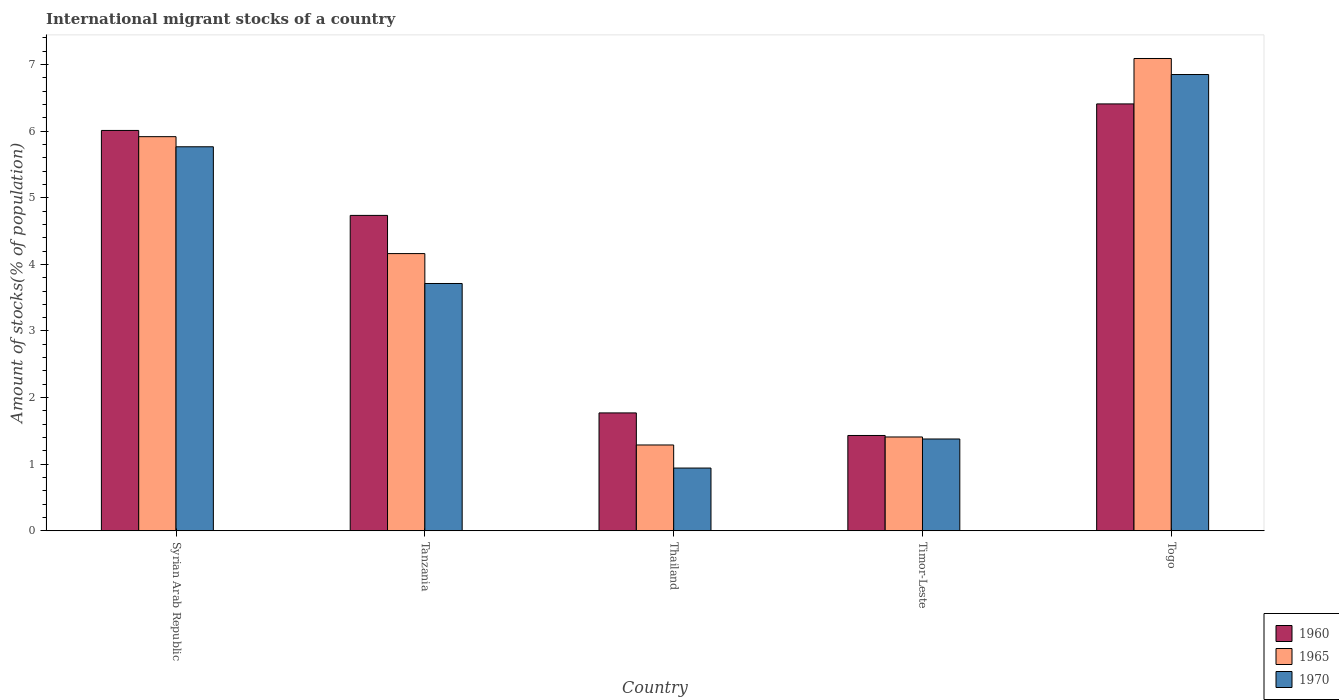How many different coloured bars are there?
Give a very brief answer. 3. How many bars are there on the 1st tick from the left?
Make the answer very short. 3. What is the label of the 5th group of bars from the left?
Keep it short and to the point. Togo. In how many cases, is the number of bars for a given country not equal to the number of legend labels?
Keep it short and to the point. 0. What is the amount of stocks in in 1970 in Syrian Arab Republic?
Your response must be concise. 5.77. Across all countries, what is the maximum amount of stocks in in 1970?
Make the answer very short. 6.85. Across all countries, what is the minimum amount of stocks in in 1970?
Your response must be concise. 0.94. In which country was the amount of stocks in in 1965 maximum?
Your response must be concise. Togo. In which country was the amount of stocks in in 1960 minimum?
Provide a short and direct response. Timor-Leste. What is the total amount of stocks in in 1970 in the graph?
Provide a short and direct response. 18.65. What is the difference between the amount of stocks in in 1970 in Syrian Arab Republic and that in Tanzania?
Provide a short and direct response. 2.05. What is the difference between the amount of stocks in in 1965 in Timor-Leste and the amount of stocks in in 1960 in Thailand?
Your answer should be compact. -0.36. What is the average amount of stocks in in 1965 per country?
Offer a terse response. 3.97. What is the difference between the amount of stocks in of/in 1970 and amount of stocks in of/in 1965 in Thailand?
Provide a short and direct response. -0.35. What is the ratio of the amount of stocks in in 1965 in Syrian Arab Republic to that in Thailand?
Keep it short and to the point. 4.59. Is the amount of stocks in in 1960 in Timor-Leste less than that in Togo?
Make the answer very short. Yes. What is the difference between the highest and the second highest amount of stocks in in 1960?
Your answer should be very brief. -1.67. What is the difference between the highest and the lowest amount of stocks in in 1970?
Offer a very short reply. 5.91. In how many countries, is the amount of stocks in in 1960 greater than the average amount of stocks in in 1960 taken over all countries?
Your answer should be compact. 3. What does the 2nd bar from the left in Timor-Leste represents?
Provide a succinct answer. 1965. What is the difference between two consecutive major ticks on the Y-axis?
Your response must be concise. 1. Are the values on the major ticks of Y-axis written in scientific E-notation?
Provide a short and direct response. No. Does the graph contain grids?
Make the answer very short. No. How many legend labels are there?
Your answer should be very brief. 3. How are the legend labels stacked?
Keep it short and to the point. Vertical. What is the title of the graph?
Your response must be concise. International migrant stocks of a country. Does "2015" appear as one of the legend labels in the graph?
Your answer should be very brief. No. What is the label or title of the Y-axis?
Offer a terse response. Amount of stocks(% of population). What is the Amount of stocks(% of population) in 1960 in Syrian Arab Republic?
Keep it short and to the point. 6.01. What is the Amount of stocks(% of population) in 1965 in Syrian Arab Republic?
Offer a very short reply. 5.92. What is the Amount of stocks(% of population) in 1970 in Syrian Arab Republic?
Ensure brevity in your answer.  5.77. What is the Amount of stocks(% of population) in 1960 in Tanzania?
Ensure brevity in your answer.  4.73. What is the Amount of stocks(% of population) in 1965 in Tanzania?
Offer a very short reply. 4.16. What is the Amount of stocks(% of population) of 1970 in Tanzania?
Make the answer very short. 3.71. What is the Amount of stocks(% of population) of 1960 in Thailand?
Make the answer very short. 1.77. What is the Amount of stocks(% of population) of 1965 in Thailand?
Keep it short and to the point. 1.29. What is the Amount of stocks(% of population) in 1970 in Thailand?
Your response must be concise. 0.94. What is the Amount of stocks(% of population) in 1960 in Timor-Leste?
Offer a very short reply. 1.43. What is the Amount of stocks(% of population) of 1965 in Timor-Leste?
Offer a terse response. 1.41. What is the Amount of stocks(% of population) in 1970 in Timor-Leste?
Make the answer very short. 1.38. What is the Amount of stocks(% of population) in 1960 in Togo?
Make the answer very short. 6.41. What is the Amount of stocks(% of population) in 1965 in Togo?
Give a very brief answer. 7.09. What is the Amount of stocks(% of population) of 1970 in Togo?
Your answer should be compact. 6.85. Across all countries, what is the maximum Amount of stocks(% of population) in 1960?
Keep it short and to the point. 6.41. Across all countries, what is the maximum Amount of stocks(% of population) of 1965?
Give a very brief answer. 7.09. Across all countries, what is the maximum Amount of stocks(% of population) in 1970?
Give a very brief answer. 6.85. Across all countries, what is the minimum Amount of stocks(% of population) in 1960?
Make the answer very short. 1.43. Across all countries, what is the minimum Amount of stocks(% of population) in 1965?
Your answer should be compact. 1.29. Across all countries, what is the minimum Amount of stocks(% of population) in 1970?
Your answer should be compact. 0.94. What is the total Amount of stocks(% of population) in 1960 in the graph?
Your response must be concise. 20.35. What is the total Amount of stocks(% of population) of 1965 in the graph?
Your response must be concise. 19.87. What is the total Amount of stocks(% of population) of 1970 in the graph?
Offer a terse response. 18.65. What is the difference between the Amount of stocks(% of population) in 1960 in Syrian Arab Republic and that in Tanzania?
Ensure brevity in your answer.  1.28. What is the difference between the Amount of stocks(% of population) of 1965 in Syrian Arab Republic and that in Tanzania?
Offer a very short reply. 1.76. What is the difference between the Amount of stocks(% of population) in 1970 in Syrian Arab Republic and that in Tanzania?
Make the answer very short. 2.05. What is the difference between the Amount of stocks(% of population) of 1960 in Syrian Arab Republic and that in Thailand?
Ensure brevity in your answer.  4.24. What is the difference between the Amount of stocks(% of population) of 1965 in Syrian Arab Republic and that in Thailand?
Give a very brief answer. 4.63. What is the difference between the Amount of stocks(% of population) of 1970 in Syrian Arab Republic and that in Thailand?
Offer a very short reply. 4.82. What is the difference between the Amount of stocks(% of population) of 1960 in Syrian Arab Republic and that in Timor-Leste?
Your answer should be very brief. 4.58. What is the difference between the Amount of stocks(% of population) of 1965 in Syrian Arab Republic and that in Timor-Leste?
Offer a very short reply. 4.51. What is the difference between the Amount of stocks(% of population) of 1970 in Syrian Arab Republic and that in Timor-Leste?
Provide a short and direct response. 4.39. What is the difference between the Amount of stocks(% of population) of 1960 in Syrian Arab Republic and that in Togo?
Offer a terse response. -0.4. What is the difference between the Amount of stocks(% of population) of 1965 in Syrian Arab Republic and that in Togo?
Offer a very short reply. -1.17. What is the difference between the Amount of stocks(% of population) of 1970 in Syrian Arab Republic and that in Togo?
Your answer should be very brief. -1.08. What is the difference between the Amount of stocks(% of population) in 1960 in Tanzania and that in Thailand?
Offer a terse response. 2.97. What is the difference between the Amount of stocks(% of population) in 1965 in Tanzania and that in Thailand?
Your answer should be very brief. 2.87. What is the difference between the Amount of stocks(% of population) of 1970 in Tanzania and that in Thailand?
Your answer should be compact. 2.77. What is the difference between the Amount of stocks(% of population) of 1960 in Tanzania and that in Timor-Leste?
Make the answer very short. 3.3. What is the difference between the Amount of stocks(% of population) of 1965 in Tanzania and that in Timor-Leste?
Ensure brevity in your answer.  2.75. What is the difference between the Amount of stocks(% of population) in 1970 in Tanzania and that in Timor-Leste?
Make the answer very short. 2.33. What is the difference between the Amount of stocks(% of population) of 1960 in Tanzania and that in Togo?
Give a very brief answer. -1.67. What is the difference between the Amount of stocks(% of population) in 1965 in Tanzania and that in Togo?
Offer a terse response. -2.93. What is the difference between the Amount of stocks(% of population) of 1970 in Tanzania and that in Togo?
Offer a terse response. -3.14. What is the difference between the Amount of stocks(% of population) in 1960 in Thailand and that in Timor-Leste?
Make the answer very short. 0.34. What is the difference between the Amount of stocks(% of population) in 1965 in Thailand and that in Timor-Leste?
Give a very brief answer. -0.12. What is the difference between the Amount of stocks(% of population) in 1970 in Thailand and that in Timor-Leste?
Offer a terse response. -0.44. What is the difference between the Amount of stocks(% of population) in 1960 in Thailand and that in Togo?
Ensure brevity in your answer.  -4.64. What is the difference between the Amount of stocks(% of population) of 1965 in Thailand and that in Togo?
Offer a terse response. -5.8. What is the difference between the Amount of stocks(% of population) of 1970 in Thailand and that in Togo?
Provide a succinct answer. -5.91. What is the difference between the Amount of stocks(% of population) in 1960 in Timor-Leste and that in Togo?
Make the answer very short. -4.98. What is the difference between the Amount of stocks(% of population) of 1965 in Timor-Leste and that in Togo?
Keep it short and to the point. -5.68. What is the difference between the Amount of stocks(% of population) in 1970 in Timor-Leste and that in Togo?
Provide a succinct answer. -5.47. What is the difference between the Amount of stocks(% of population) of 1960 in Syrian Arab Republic and the Amount of stocks(% of population) of 1965 in Tanzania?
Offer a terse response. 1.85. What is the difference between the Amount of stocks(% of population) in 1960 in Syrian Arab Republic and the Amount of stocks(% of population) in 1970 in Tanzania?
Give a very brief answer. 2.3. What is the difference between the Amount of stocks(% of population) of 1965 in Syrian Arab Republic and the Amount of stocks(% of population) of 1970 in Tanzania?
Give a very brief answer. 2.2. What is the difference between the Amount of stocks(% of population) of 1960 in Syrian Arab Republic and the Amount of stocks(% of population) of 1965 in Thailand?
Your answer should be compact. 4.72. What is the difference between the Amount of stocks(% of population) of 1960 in Syrian Arab Republic and the Amount of stocks(% of population) of 1970 in Thailand?
Provide a short and direct response. 5.07. What is the difference between the Amount of stocks(% of population) in 1965 in Syrian Arab Republic and the Amount of stocks(% of population) in 1970 in Thailand?
Your response must be concise. 4.98. What is the difference between the Amount of stocks(% of population) of 1960 in Syrian Arab Republic and the Amount of stocks(% of population) of 1965 in Timor-Leste?
Give a very brief answer. 4.6. What is the difference between the Amount of stocks(% of population) in 1960 in Syrian Arab Republic and the Amount of stocks(% of population) in 1970 in Timor-Leste?
Offer a terse response. 4.63. What is the difference between the Amount of stocks(% of population) in 1965 in Syrian Arab Republic and the Amount of stocks(% of population) in 1970 in Timor-Leste?
Your response must be concise. 4.54. What is the difference between the Amount of stocks(% of population) of 1960 in Syrian Arab Republic and the Amount of stocks(% of population) of 1965 in Togo?
Your response must be concise. -1.08. What is the difference between the Amount of stocks(% of population) of 1960 in Syrian Arab Republic and the Amount of stocks(% of population) of 1970 in Togo?
Provide a short and direct response. -0.84. What is the difference between the Amount of stocks(% of population) of 1965 in Syrian Arab Republic and the Amount of stocks(% of population) of 1970 in Togo?
Offer a very short reply. -0.93. What is the difference between the Amount of stocks(% of population) in 1960 in Tanzania and the Amount of stocks(% of population) in 1965 in Thailand?
Ensure brevity in your answer.  3.45. What is the difference between the Amount of stocks(% of population) of 1960 in Tanzania and the Amount of stocks(% of population) of 1970 in Thailand?
Your answer should be compact. 3.79. What is the difference between the Amount of stocks(% of population) in 1965 in Tanzania and the Amount of stocks(% of population) in 1970 in Thailand?
Ensure brevity in your answer.  3.22. What is the difference between the Amount of stocks(% of population) in 1960 in Tanzania and the Amount of stocks(% of population) in 1965 in Timor-Leste?
Your response must be concise. 3.33. What is the difference between the Amount of stocks(% of population) in 1960 in Tanzania and the Amount of stocks(% of population) in 1970 in Timor-Leste?
Make the answer very short. 3.36. What is the difference between the Amount of stocks(% of population) in 1965 in Tanzania and the Amount of stocks(% of population) in 1970 in Timor-Leste?
Keep it short and to the point. 2.78. What is the difference between the Amount of stocks(% of population) in 1960 in Tanzania and the Amount of stocks(% of population) in 1965 in Togo?
Ensure brevity in your answer.  -2.36. What is the difference between the Amount of stocks(% of population) in 1960 in Tanzania and the Amount of stocks(% of population) in 1970 in Togo?
Your answer should be compact. -2.12. What is the difference between the Amount of stocks(% of population) in 1965 in Tanzania and the Amount of stocks(% of population) in 1970 in Togo?
Your answer should be compact. -2.69. What is the difference between the Amount of stocks(% of population) of 1960 in Thailand and the Amount of stocks(% of population) of 1965 in Timor-Leste?
Offer a very short reply. 0.36. What is the difference between the Amount of stocks(% of population) of 1960 in Thailand and the Amount of stocks(% of population) of 1970 in Timor-Leste?
Give a very brief answer. 0.39. What is the difference between the Amount of stocks(% of population) in 1965 in Thailand and the Amount of stocks(% of population) in 1970 in Timor-Leste?
Provide a short and direct response. -0.09. What is the difference between the Amount of stocks(% of population) in 1960 in Thailand and the Amount of stocks(% of population) in 1965 in Togo?
Keep it short and to the point. -5.32. What is the difference between the Amount of stocks(% of population) in 1960 in Thailand and the Amount of stocks(% of population) in 1970 in Togo?
Offer a terse response. -5.08. What is the difference between the Amount of stocks(% of population) of 1965 in Thailand and the Amount of stocks(% of population) of 1970 in Togo?
Your answer should be very brief. -5.56. What is the difference between the Amount of stocks(% of population) of 1960 in Timor-Leste and the Amount of stocks(% of population) of 1965 in Togo?
Your answer should be very brief. -5.66. What is the difference between the Amount of stocks(% of population) in 1960 in Timor-Leste and the Amount of stocks(% of population) in 1970 in Togo?
Your response must be concise. -5.42. What is the difference between the Amount of stocks(% of population) in 1965 in Timor-Leste and the Amount of stocks(% of population) in 1970 in Togo?
Provide a succinct answer. -5.44. What is the average Amount of stocks(% of population) in 1960 per country?
Your answer should be compact. 4.07. What is the average Amount of stocks(% of population) in 1965 per country?
Give a very brief answer. 3.97. What is the average Amount of stocks(% of population) in 1970 per country?
Your answer should be very brief. 3.73. What is the difference between the Amount of stocks(% of population) of 1960 and Amount of stocks(% of population) of 1965 in Syrian Arab Republic?
Provide a succinct answer. 0.09. What is the difference between the Amount of stocks(% of population) of 1960 and Amount of stocks(% of population) of 1970 in Syrian Arab Republic?
Give a very brief answer. 0.25. What is the difference between the Amount of stocks(% of population) of 1965 and Amount of stocks(% of population) of 1970 in Syrian Arab Republic?
Your answer should be very brief. 0.15. What is the difference between the Amount of stocks(% of population) of 1960 and Amount of stocks(% of population) of 1965 in Tanzania?
Give a very brief answer. 0.57. What is the difference between the Amount of stocks(% of population) of 1960 and Amount of stocks(% of population) of 1970 in Tanzania?
Give a very brief answer. 1.02. What is the difference between the Amount of stocks(% of population) of 1965 and Amount of stocks(% of population) of 1970 in Tanzania?
Provide a short and direct response. 0.45. What is the difference between the Amount of stocks(% of population) in 1960 and Amount of stocks(% of population) in 1965 in Thailand?
Ensure brevity in your answer.  0.48. What is the difference between the Amount of stocks(% of population) in 1960 and Amount of stocks(% of population) in 1970 in Thailand?
Offer a very short reply. 0.83. What is the difference between the Amount of stocks(% of population) in 1965 and Amount of stocks(% of population) in 1970 in Thailand?
Offer a very short reply. 0.35. What is the difference between the Amount of stocks(% of population) in 1960 and Amount of stocks(% of population) in 1965 in Timor-Leste?
Make the answer very short. 0.02. What is the difference between the Amount of stocks(% of population) in 1960 and Amount of stocks(% of population) in 1970 in Timor-Leste?
Offer a very short reply. 0.05. What is the difference between the Amount of stocks(% of population) in 1965 and Amount of stocks(% of population) in 1970 in Timor-Leste?
Offer a very short reply. 0.03. What is the difference between the Amount of stocks(% of population) of 1960 and Amount of stocks(% of population) of 1965 in Togo?
Provide a short and direct response. -0.68. What is the difference between the Amount of stocks(% of population) of 1960 and Amount of stocks(% of population) of 1970 in Togo?
Your answer should be very brief. -0.44. What is the difference between the Amount of stocks(% of population) of 1965 and Amount of stocks(% of population) of 1970 in Togo?
Offer a terse response. 0.24. What is the ratio of the Amount of stocks(% of population) of 1960 in Syrian Arab Republic to that in Tanzania?
Give a very brief answer. 1.27. What is the ratio of the Amount of stocks(% of population) of 1965 in Syrian Arab Republic to that in Tanzania?
Provide a succinct answer. 1.42. What is the ratio of the Amount of stocks(% of population) of 1970 in Syrian Arab Republic to that in Tanzania?
Provide a short and direct response. 1.55. What is the ratio of the Amount of stocks(% of population) in 1960 in Syrian Arab Republic to that in Thailand?
Ensure brevity in your answer.  3.4. What is the ratio of the Amount of stocks(% of population) in 1965 in Syrian Arab Republic to that in Thailand?
Provide a succinct answer. 4.59. What is the ratio of the Amount of stocks(% of population) of 1970 in Syrian Arab Republic to that in Thailand?
Provide a short and direct response. 6.12. What is the ratio of the Amount of stocks(% of population) of 1960 in Syrian Arab Republic to that in Timor-Leste?
Make the answer very short. 4.2. What is the ratio of the Amount of stocks(% of population) in 1965 in Syrian Arab Republic to that in Timor-Leste?
Make the answer very short. 4.2. What is the ratio of the Amount of stocks(% of population) of 1970 in Syrian Arab Republic to that in Timor-Leste?
Provide a short and direct response. 4.18. What is the ratio of the Amount of stocks(% of population) in 1960 in Syrian Arab Republic to that in Togo?
Provide a short and direct response. 0.94. What is the ratio of the Amount of stocks(% of population) in 1965 in Syrian Arab Republic to that in Togo?
Keep it short and to the point. 0.83. What is the ratio of the Amount of stocks(% of population) of 1970 in Syrian Arab Republic to that in Togo?
Ensure brevity in your answer.  0.84. What is the ratio of the Amount of stocks(% of population) of 1960 in Tanzania to that in Thailand?
Your response must be concise. 2.68. What is the ratio of the Amount of stocks(% of population) in 1965 in Tanzania to that in Thailand?
Ensure brevity in your answer.  3.23. What is the ratio of the Amount of stocks(% of population) in 1970 in Tanzania to that in Thailand?
Offer a very short reply. 3.94. What is the ratio of the Amount of stocks(% of population) in 1960 in Tanzania to that in Timor-Leste?
Your response must be concise. 3.31. What is the ratio of the Amount of stocks(% of population) in 1965 in Tanzania to that in Timor-Leste?
Make the answer very short. 2.95. What is the ratio of the Amount of stocks(% of population) of 1970 in Tanzania to that in Timor-Leste?
Your response must be concise. 2.69. What is the ratio of the Amount of stocks(% of population) of 1960 in Tanzania to that in Togo?
Your answer should be very brief. 0.74. What is the ratio of the Amount of stocks(% of population) in 1965 in Tanzania to that in Togo?
Make the answer very short. 0.59. What is the ratio of the Amount of stocks(% of population) in 1970 in Tanzania to that in Togo?
Provide a short and direct response. 0.54. What is the ratio of the Amount of stocks(% of population) in 1960 in Thailand to that in Timor-Leste?
Provide a succinct answer. 1.24. What is the ratio of the Amount of stocks(% of population) of 1965 in Thailand to that in Timor-Leste?
Offer a very short reply. 0.91. What is the ratio of the Amount of stocks(% of population) in 1970 in Thailand to that in Timor-Leste?
Your answer should be compact. 0.68. What is the ratio of the Amount of stocks(% of population) of 1960 in Thailand to that in Togo?
Your answer should be very brief. 0.28. What is the ratio of the Amount of stocks(% of population) in 1965 in Thailand to that in Togo?
Your answer should be very brief. 0.18. What is the ratio of the Amount of stocks(% of population) in 1970 in Thailand to that in Togo?
Give a very brief answer. 0.14. What is the ratio of the Amount of stocks(% of population) in 1960 in Timor-Leste to that in Togo?
Offer a terse response. 0.22. What is the ratio of the Amount of stocks(% of population) of 1965 in Timor-Leste to that in Togo?
Offer a very short reply. 0.2. What is the ratio of the Amount of stocks(% of population) in 1970 in Timor-Leste to that in Togo?
Give a very brief answer. 0.2. What is the difference between the highest and the second highest Amount of stocks(% of population) in 1960?
Keep it short and to the point. 0.4. What is the difference between the highest and the second highest Amount of stocks(% of population) of 1965?
Provide a succinct answer. 1.17. What is the difference between the highest and the second highest Amount of stocks(% of population) in 1970?
Provide a succinct answer. 1.08. What is the difference between the highest and the lowest Amount of stocks(% of population) of 1960?
Ensure brevity in your answer.  4.98. What is the difference between the highest and the lowest Amount of stocks(% of population) of 1965?
Provide a succinct answer. 5.8. What is the difference between the highest and the lowest Amount of stocks(% of population) of 1970?
Keep it short and to the point. 5.91. 